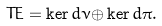<formula> <loc_0><loc_0><loc_500><loc_500>T E = \ker d \nu \mathcal { \oplus } \ker d \pi .</formula> 